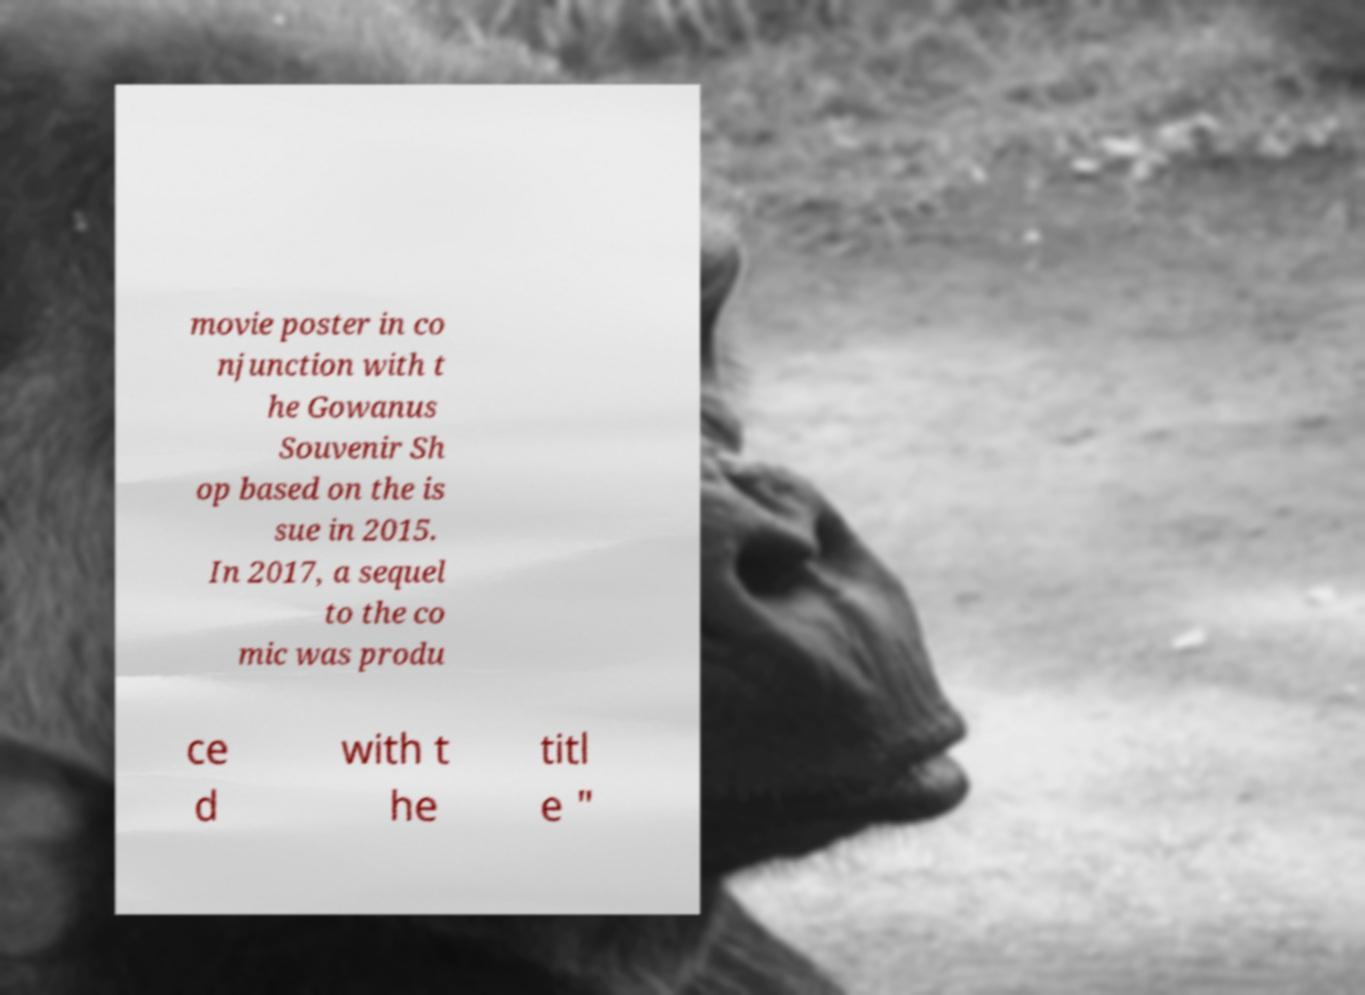What messages or text are displayed in this image? I need them in a readable, typed format. movie poster in co njunction with t he Gowanus Souvenir Sh op based on the is sue in 2015. In 2017, a sequel to the co mic was produ ce d with t he titl e " 